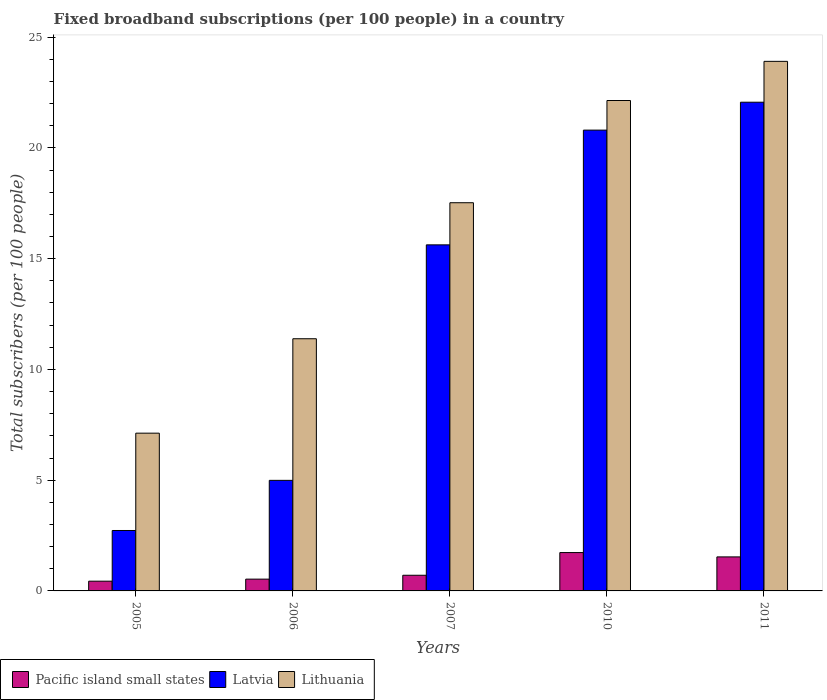How many groups of bars are there?
Make the answer very short. 5. Are the number of bars per tick equal to the number of legend labels?
Your answer should be very brief. Yes. Are the number of bars on each tick of the X-axis equal?
Keep it short and to the point. Yes. What is the label of the 5th group of bars from the left?
Make the answer very short. 2011. In how many cases, is the number of bars for a given year not equal to the number of legend labels?
Ensure brevity in your answer.  0. What is the number of broadband subscriptions in Lithuania in 2007?
Offer a terse response. 17.52. Across all years, what is the maximum number of broadband subscriptions in Pacific island small states?
Offer a very short reply. 1.73. Across all years, what is the minimum number of broadband subscriptions in Lithuania?
Your answer should be very brief. 7.12. In which year was the number of broadband subscriptions in Lithuania maximum?
Ensure brevity in your answer.  2011. In which year was the number of broadband subscriptions in Pacific island small states minimum?
Make the answer very short. 2005. What is the total number of broadband subscriptions in Pacific island small states in the graph?
Provide a succinct answer. 4.95. What is the difference between the number of broadband subscriptions in Latvia in 2007 and that in 2011?
Your answer should be compact. -6.44. What is the difference between the number of broadband subscriptions in Lithuania in 2010 and the number of broadband subscriptions in Pacific island small states in 2006?
Your answer should be very brief. 21.61. What is the average number of broadband subscriptions in Pacific island small states per year?
Keep it short and to the point. 0.99. In the year 2010, what is the difference between the number of broadband subscriptions in Pacific island small states and number of broadband subscriptions in Latvia?
Offer a terse response. -19.07. In how many years, is the number of broadband subscriptions in Lithuania greater than 21?
Ensure brevity in your answer.  2. What is the ratio of the number of broadband subscriptions in Latvia in 2007 to that in 2011?
Your answer should be compact. 0.71. What is the difference between the highest and the second highest number of broadband subscriptions in Lithuania?
Your answer should be very brief. 1.77. What is the difference between the highest and the lowest number of broadband subscriptions in Latvia?
Ensure brevity in your answer.  19.33. In how many years, is the number of broadband subscriptions in Latvia greater than the average number of broadband subscriptions in Latvia taken over all years?
Your answer should be very brief. 3. What does the 3rd bar from the left in 2007 represents?
Provide a short and direct response. Lithuania. What does the 3rd bar from the right in 2007 represents?
Ensure brevity in your answer.  Pacific island small states. Is it the case that in every year, the sum of the number of broadband subscriptions in Latvia and number of broadband subscriptions in Lithuania is greater than the number of broadband subscriptions in Pacific island small states?
Your answer should be compact. Yes. How many years are there in the graph?
Keep it short and to the point. 5. What is the difference between two consecutive major ticks on the Y-axis?
Keep it short and to the point. 5. Where does the legend appear in the graph?
Your response must be concise. Bottom left. How are the legend labels stacked?
Your answer should be very brief. Horizontal. What is the title of the graph?
Your answer should be compact. Fixed broadband subscriptions (per 100 people) in a country. What is the label or title of the Y-axis?
Give a very brief answer. Total subscribers (per 100 people). What is the Total subscribers (per 100 people) of Pacific island small states in 2005?
Your answer should be very brief. 0.44. What is the Total subscribers (per 100 people) of Latvia in 2005?
Your response must be concise. 2.73. What is the Total subscribers (per 100 people) of Lithuania in 2005?
Give a very brief answer. 7.12. What is the Total subscribers (per 100 people) in Pacific island small states in 2006?
Provide a succinct answer. 0.53. What is the Total subscribers (per 100 people) in Latvia in 2006?
Offer a very short reply. 4.99. What is the Total subscribers (per 100 people) in Lithuania in 2006?
Provide a succinct answer. 11.38. What is the Total subscribers (per 100 people) in Pacific island small states in 2007?
Give a very brief answer. 0.71. What is the Total subscribers (per 100 people) in Latvia in 2007?
Offer a very short reply. 15.62. What is the Total subscribers (per 100 people) in Lithuania in 2007?
Your response must be concise. 17.52. What is the Total subscribers (per 100 people) of Pacific island small states in 2010?
Make the answer very short. 1.73. What is the Total subscribers (per 100 people) of Latvia in 2010?
Your response must be concise. 20.8. What is the Total subscribers (per 100 people) in Lithuania in 2010?
Provide a short and direct response. 22.14. What is the Total subscribers (per 100 people) in Pacific island small states in 2011?
Provide a short and direct response. 1.54. What is the Total subscribers (per 100 people) in Latvia in 2011?
Give a very brief answer. 22.06. What is the Total subscribers (per 100 people) of Lithuania in 2011?
Offer a terse response. 23.91. Across all years, what is the maximum Total subscribers (per 100 people) in Pacific island small states?
Provide a short and direct response. 1.73. Across all years, what is the maximum Total subscribers (per 100 people) of Latvia?
Offer a very short reply. 22.06. Across all years, what is the maximum Total subscribers (per 100 people) in Lithuania?
Keep it short and to the point. 23.91. Across all years, what is the minimum Total subscribers (per 100 people) in Pacific island small states?
Keep it short and to the point. 0.44. Across all years, what is the minimum Total subscribers (per 100 people) of Latvia?
Provide a succinct answer. 2.73. Across all years, what is the minimum Total subscribers (per 100 people) in Lithuania?
Give a very brief answer. 7.12. What is the total Total subscribers (per 100 people) of Pacific island small states in the graph?
Provide a succinct answer. 4.95. What is the total Total subscribers (per 100 people) of Latvia in the graph?
Your answer should be very brief. 66.21. What is the total Total subscribers (per 100 people) in Lithuania in the graph?
Provide a short and direct response. 82.08. What is the difference between the Total subscribers (per 100 people) in Pacific island small states in 2005 and that in 2006?
Provide a succinct answer. -0.09. What is the difference between the Total subscribers (per 100 people) in Latvia in 2005 and that in 2006?
Keep it short and to the point. -2.26. What is the difference between the Total subscribers (per 100 people) in Lithuania in 2005 and that in 2006?
Provide a short and direct response. -4.26. What is the difference between the Total subscribers (per 100 people) of Pacific island small states in 2005 and that in 2007?
Your response must be concise. -0.27. What is the difference between the Total subscribers (per 100 people) in Latvia in 2005 and that in 2007?
Offer a terse response. -12.89. What is the difference between the Total subscribers (per 100 people) of Lithuania in 2005 and that in 2007?
Your answer should be very brief. -10.4. What is the difference between the Total subscribers (per 100 people) in Pacific island small states in 2005 and that in 2010?
Provide a succinct answer. -1.29. What is the difference between the Total subscribers (per 100 people) of Latvia in 2005 and that in 2010?
Offer a very short reply. -18.07. What is the difference between the Total subscribers (per 100 people) in Lithuania in 2005 and that in 2010?
Your answer should be very brief. -15.02. What is the difference between the Total subscribers (per 100 people) of Pacific island small states in 2005 and that in 2011?
Your response must be concise. -1.1. What is the difference between the Total subscribers (per 100 people) in Latvia in 2005 and that in 2011?
Provide a short and direct response. -19.33. What is the difference between the Total subscribers (per 100 people) of Lithuania in 2005 and that in 2011?
Keep it short and to the point. -16.78. What is the difference between the Total subscribers (per 100 people) in Pacific island small states in 2006 and that in 2007?
Your answer should be very brief. -0.18. What is the difference between the Total subscribers (per 100 people) of Latvia in 2006 and that in 2007?
Your answer should be very brief. -10.63. What is the difference between the Total subscribers (per 100 people) of Lithuania in 2006 and that in 2007?
Provide a succinct answer. -6.14. What is the difference between the Total subscribers (per 100 people) in Pacific island small states in 2006 and that in 2010?
Make the answer very short. -1.2. What is the difference between the Total subscribers (per 100 people) in Latvia in 2006 and that in 2010?
Make the answer very short. -15.81. What is the difference between the Total subscribers (per 100 people) of Lithuania in 2006 and that in 2010?
Your response must be concise. -10.75. What is the difference between the Total subscribers (per 100 people) in Pacific island small states in 2006 and that in 2011?
Offer a terse response. -1. What is the difference between the Total subscribers (per 100 people) in Latvia in 2006 and that in 2011?
Offer a very short reply. -17.07. What is the difference between the Total subscribers (per 100 people) of Lithuania in 2006 and that in 2011?
Provide a succinct answer. -12.52. What is the difference between the Total subscribers (per 100 people) of Pacific island small states in 2007 and that in 2010?
Give a very brief answer. -1.02. What is the difference between the Total subscribers (per 100 people) of Latvia in 2007 and that in 2010?
Keep it short and to the point. -5.18. What is the difference between the Total subscribers (per 100 people) of Lithuania in 2007 and that in 2010?
Provide a short and direct response. -4.61. What is the difference between the Total subscribers (per 100 people) of Pacific island small states in 2007 and that in 2011?
Keep it short and to the point. -0.83. What is the difference between the Total subscribers (per 100 people) in Latvia in 2007 and that in 2011?
Offer a very short reply. -6.44. What is the difference between the Total subscribers (per 100 people) in Lithuania in 2007 and that in 2011?
Your answer should be compact. -6.38. What is the difference between the Total subscribers (per 100 people) in Pacific island small states in 2010 and that in 2011?
Offer a very short reply. 0.2. What is the difference between the Total subscribers (per 100 people) in Latvia in 2010 and that in 2011?
Your answer should be very brief. -1.26. What is the difference between the Total subscribers (per 100 people) in Lithuania in 2010 and that in 2011?
Keep it short and to the point. -1.77. What is the difference between the Total subscribers (per 100 people) of Pacific island small states in 2005 and the Total subscribers (per 100 people) of Latvia in 2006?
Provide a short and direct response. -4.55. What is the difference between the Total subscribers (per 100 people) of Pacific island small states in 2005 and the Total subscribers (per 100 people) of Lithuania in 2006?
Give a very brief answer. -10.94. What is the difference between the Total subscribers (per 100 people) in Latvia in 2005 and the Total subscribers (per 100 people) in Lithuania in 2006?
Offer a very short reply. -8.66. What is the difference between the Total subscribers (per 100 people) of Pacific island small states in 2005 and the Total subscribers (per 100 people) of Latvia in 2007?
Your answer should be compact. -15.18. What is the difference between the Total subscribers (per 100 people) of Pacific island small states in 2005 and the Total subscribers (per 100 people) of Lithuania in 2007?
Make the answer very short. -17.08. What is the difference between the Total subscribers (per 100 people) of Latvia in 2005 and the Total subscribers (per 100 people) of Lithuania in 2007?
Keep it short and to the point. -14.8. What is the difference between the Total subscribers (per 100 people) in Pacific island small states in 2005 and the Total subscribers (per 100 people) in Latvia in 2010?
Offer a terse response. -20.36. What is the difference between the Total subscribers (per 100 people) of Pacific island small states in 2005 and the Total subscribers (per 100 people) of Lithuania in 2010?
Give a very brief answer. -21.7. What is the difference between the Total subscribers (per 100 people) of Latvia in 2005 and the Total subscribers (per 100 people) of Lithuania in 2010?
Give a very brief answer. -19.41. What is the difference between the Total subscribers (per 100 people) in Pacific island small states in 2005 and the Total subscribers (per 100 people) in Latvia in 2011?
Your answer should be compact. -21.62. What is the difference between the Total subscribers (per 100 people) of Pacific island small states in 2005 and the Total subscribers (per 100 people) of Lithuania in 2011?
Offer a terse response. -23.47. What is the difference between the Total subscribers (per 100 people) in Latvia in 2005 and the Total subscribers (per 100 people) in Lithuania in 2011?
Keep it short and to the point. -21.18. What is the difference between the Total subscribers (per 100 people) in Pacific island small states in 2006 and the Total subscribers (per 100 people) in Latvia in 2007?
Keep it short and to the point. -15.09. What is the difference between the Total subscribers (per 100 people) of Pacific island small states in 2006 and the Total subscribers (per 100 people) of Lithuania in 2007?
Keep it short and to the point. -16.99. What is the difference between the Total subscribers (per 100 people) of Latvia in 2006 and the Total subscribers (per 100 people) of Lithuania in 2007?
Your response must be concise. -12.53. What is the difference between the Total subscribers (per 100 people) of Pacific island small states in 2006 and the Total subscribers (per 100 people) of Latvia in 2010?
Your answer should be compact. -20.27. What is the difference between the Total subscribers (per 100 people) of Pacific island small states in 2006 and the Total subscribers (per 100 people) of Lithuania in 2010?
Provide a succinct answer. -21.61. What is the difference between the Total subscribers (per 100 people) of Latvia in 2006 and the Total subscribers (per 100 people) of Lithuania in 2010?
Your response must be concise. -17.15. What is the difference between the Total subscribers (per 100 people) of Pacific island small states in 2006 and the Total subscribers (per 100 people) of Latvia in 2011?
Offer a terse response. -21.53. What is the difference between the Total subscribers (per 100 people) in Pacific island small states in 2006 and the Total subscribers (per 100 people) in Lithuania in 2011?
Give a very brief answer. -23.37. What is the difference between the Total subscribers (per 100 people) in Latvia in 2006 and the Total subscribers (per 100 people) in Lithuania in 2011?
Offer a very short reply. -18.91. What is the difference between the Total subscribers (per 100 people) of Pacific island small states in 2007 and the Total subscribers (per 100 people) of Latvia in 2010?
Provide a succinct answer. -20.1. What is the difference between the Total subscribers (per 100 people) in Pacific island small states in 2007 and the Total subscribers (per 100 people) in Lithuania in 2010?
Keep it short and to the point. -21.43. What is the difference between the Total subscribers (per 100 people) of Latvia in 2007 and the Total subscribers (per 100 people) of Lithuania in 2010?
Your response must be concise. -6.52. What is the difference between the Total subscribers (per 100 people) of Pacific island small states in 2007 and the Total subscribers (per 100 people) of Latvia in 2011?
Your response must be concise. -21.35. What is the difference between the Total subscribers (per 100 people) in Pacific island small states in 2007 and the Total subscribers (per 100 people) in Lithuania in 2011?
Provide a short and direct response. -23.2. What is the difference between the Total subscribers (per 100 people) in Latvia in 2007 and the Total subscribers (per 100 people) in Lithuania in 2011?
Offer a terse response. -8.28. What is the difference between the Total subscribers (per 100 people) in Pacific island small states in 2010 and the Total subscribers (per 100 people) in Latvia in 2011?
Your answer should be compact. -20.33. What is the difference between the Total subscribers (per 100 people) in Pacific island small states in 2010 and the Total subscribers (per 100 people) in Lithuania in 2011?
Give a very brief answer. -22.17. What is the difference between the Total subscribers (per 100 people) in Latvia in 2010 and the Total subscribers (per 100 people) in Lithuania in 2011?
Provide a short and direct response. -3.1. What is the average Total subscribers (per 100 people) in Pacific island small states per year?
Provide a succinct answer. 0.99. What is the average Total subscribers (per 100 people) of Latvia per year?
Ensure brevity in your answer.  13.24. What is the average Total subscribers (per 100 people) in Lithuania per year?
Provide a short and direct response. 16.42. In the year 2005, what is the difference between the Total subscribers (per 100 people) in Pacific island small states and Total subscribers (per 100 people) in Latvia?
Offer a terse response. -2.29. In the year 2005, what is the difference between the Total subscribers (per 100 people) in Pacific island small states and Total subscribers (per 100 people) in Lithuania?
Make the answer very short. -6.68. In the year 2005, what is the difference between the Total subscribers (per 100 people) in Latvia and Total subscribers (per 100 people) in Lithuania?
Offer a very short reply. -4.39. In the year 2006, what is the difference between the Total subscribers (per 100 people) in Pacific island small states and Total subscribers (per 100 people) in Latvia?
Offer a very short reply. -4.46. In the year 2006, what is the difference between the Total subscribers (per 100 people) of Pacific island small states and Total subscribers (per 100 people) of Lithuania?
Give a very brief answer. -10.85. In the year 2006, what is the difference between the Total subscribers (per 100 people) in Latvia and Total subscribers (per 100 people) in Lithuania?
Provide a succinct answer. -6.39. In the year 2007, what is the difference between the Total subscribers (per 100 people) of Pacific island small states and Total subscribers (per 100 people) of Latvia?
Ensure brevity in your answer.  -14.91. In the year 2007, what is the difference between the Total subscribers (per 100 people) of Pacific island small states and Total subscribers (per 100 people) of Lithuania?
Your answer should be very brief. -16.82. In the year 2007, what is the difference between the Total subscribers (per 100 people) of Latvia and Total subscribers (per 100 people) of Lithuania?
Your response must be concise. -1.9. In the year 2010, what is the difference between the Total subscribers (per 100 people) in Pacific island small states and Total subscribers (per 100 people) in Latvia?
Give a very brief answer. -19.07. In the year 2010, what is the difference between the Total subscribers (per 100 people) in Pacific island small states and Total subscribers (per 100 people) in Lithuania?
Your response must be concise. -20.41. In the year 2010, what is the difference between the Total subscribers (per 100 people) of Latvia and Total subscribers (per 100 people) of Lithuania?
Ensure brevity in your answer.  -1.34. In the year 2011, what is the difference between the Total subscribers (per 100 people) of Pacific island small states and Total subscribers (per 100 people) of Latvia?
Your answer should be very brief. -20.53. In the year 2011, what is the difference between the Total subscribers (per 100 people) in Pacific island small states and Total subscribers (per 100 people) in Lithuania?
Provide a short and direct response. -22.37. In the year 2011, what is the difference between the Total subscribers (per 100 people) in Latvia and Total subscribers (per 100 people) in Lithuania?
Provide a short and direct response. -1.84. What is the ratio of the Total subscribers (per 100 people) in Pacific island small states in 2005 to that in 2006?
Ensure brevity in your answer.  0.83. What is the ratio of the Total subscribers (per 100 people) of Latvia in 2005 to that in 2006?
Provide a succinct answer. 0.55. What is the ratio of the Total subscribers (per 100 people) of Lithuania in 2005 to that in 2006?
Your answer should be compact. 0.63. What is the ratio of the Total subscribers (per 100 people) in Pacific island small states in 2005 to that in 2007?
Give a very brief answer. 0.62. What is the ratio of the Total subscribers (per 100 people) of Latvia in 2005 to that in 2007?
Your answer should be very brief. 0.17. What is the ratio of the Total subscribers (per 100 people) in Lithuania in 2005 to that in 2007?
Offer a very short reply. 0.41. What is the ratio of the Total subscribers (per 100 people) of Pacific island small states in 2005 to that in 2010?
Your answer should be very brief. 0.25. What is the ratio of the Total subscribers (per 100 people) in Latvia in 2005 to that in 2010?
Offer a terse response. 0.13. What is the ratio of the Total subscribers (per 100 people) in Lithuania in 2005 to that in 2010?
Your answer should be compact. 0.32. What is the ratio of the Total subscribers (per 100 people) in Pacific island small states in 2005 to that in 2011?
Offer a very short reply. 0.29. What is the ratio of the Total subscribers (per 100 people) of Latvia in 2005 to that in 2011?
Provide a succinct answer. 0.12. What is the ratio of the Total subscribers (per 100 people) of Lithuania in 2005 to that in 2011?
Provide a short and direct response. 0.3. What is the ratio of the Total subscribers (per 100 people) of Pacific island small states in 2006 to that in 2007?
Make the answer very short. 0.75. What is the ratio of the Total subscribers (per 100 people) of Latvia in 2006 to that in 2007?
Your response must be concise. 0.32. What is the ratio of the Total subscribers (per 100 people) of Lithuania in 2006 to that in 2007?
Give a very brief answer. 0.65. What is the ratio of the Total subscribers (per 100 people) in Pacific island small states in 2006 to that in 2010?
Offer a terse response. 0.31. What is the ratio of the Total subscribers (per 100 people) in Latvia in 2006 to that in 2010?
Offer a very short reply. 0.24. What is the ratio of the Total subscribers (per 100 people) of Lithuania in 2006 to that in 2010?
Make the answer very short. 0.51. What is the ratio of the Total subscribers (per 100 people) of Pacific island small states in 2006 to that in 2011?
Make the answer very short. 0.35. What is the ratio of the Total subscribers (per 100 people) in Latvia in 2006 to that in 2011?
Your response must be concise. 0.23. What is the ratio of the Total subscribers (per 100 people) in Lithuania in 2006 to that in 2011?
Offer a terse response. 0.48. What is the ratio of the Total subscribers (per 100 people) of Pacific island small states in 2007 to that in 2010?
Your response must be concise. 0.41. What is the ratio of the Total subscribers (per 100 people) in Latvia in 2007 to that in 2010?
Offer a very short reply. 0.75. What is the ratio of the Total subscribers (per 100 people) of Lithuania in 2007 to that in 2010?
Give a very brief answer. 0.79. What is the ratio of the Total subscribers (per 100 people) in Pacific island small states in 2007 to that in 2011?
Keep it short and to the point. 0.46. What is the ratio of the Total subscribers (per 100 people) of Latvia in 2007 to that in 2011?
Provide a succinct answer. 0.71. What is the ratio of the Total subscribers (per 100 people) of Lithuania in 2007 to that in 2011?
Make the answer very short. 0.73. What is the ratio of the Total subscribers (per 100 people) of Pacific island small states in 2010 to that in 2011?
Offer a terse response. 1.13. What is the ratio of the Total subscribers (per 100 people) of Latvia in 2010 to that in 2011?
Provide a short and direct response. 0.94. What is the ratio of the Total subscribers (per 100 people) of Lithuania in 2010 to that in 2011?
Make the answer very short. 0.93. What is the difference between the highest and the second highest Total subscribers (per 100 people) of Pacific island small states?
Your answer should be very brief. 0.2. What is the difference between the highest and the second highest Total subscribers (per 100 people) of Latvia?
Your response must be concise. 1.26. What is the difference between the highest and the second highest Total subscribers (per 100 people) of Lithuania?
Keep it short and to the point. 1.77. What is the difference between the highest and the lowest Total subscribers (per 100 people) of Pacific island small states?
Make the answer very short. 1.29. What is the difference between the highest and the lowest Total subscribers (per 100 people) of Latvia?
Your response must be concise. 19.33. What is the difference between the highest and the lowest Total subscribers (per 100 people) in Lithuania?
Provide a short and direct response. 16.78. 